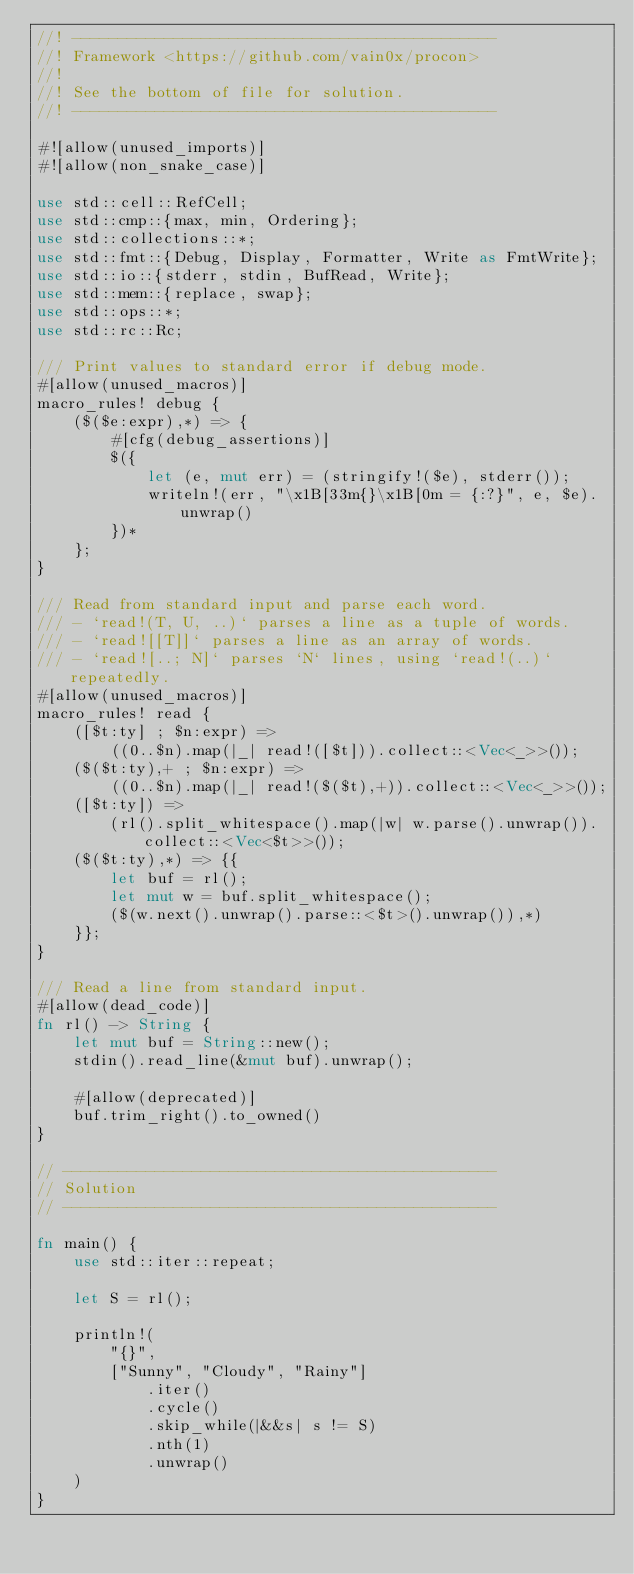Convert code to text. <code><loc_0><loc_0><loc_500><loc_500><_Rust_>//! ----------------------------------------------
//! Framework <https://github.com/vain0x/procon>
//!
//! See the bottom of file for solution.
//! ----------------------------------------------

#![allow(unused_imports)]
#![allow(non_snake_case)]

use std::cell::RefCell;
use std::cmp::{max, min, Ordering};
use std::collections::*;
use std::fmt::{Debug, Display, Formatter, Write as FmtWrite};
use std::io::{stderr, stdin, BufRead, Write};
use std::mem::{replace, swap};
use std::ops::*;
use std::rc::Rc;

/// Print values to standard error if debug mode.
#[allow(unused_macros)]
macro_rules! debug {
    ($($e:expr),*) => {
        #[cfg(debug_assertions)]
        $({
            let (e, mut err) = (stringify!($e), stderr());
            writeln!(err, "\x1B[33m{}\x1B[0m = {:?}", e, $e).unwrap()
        })*
    };
}

/// Read from standard input and parse each word.
/// - `read!(T, U, ..)` parses a line as a tuple of words.
/// - `read![[T]]` parses a line as an array of words.
/// - `read![..; N]` parses `N` lines, using `read!(..)` repeatedly.
#[allow(unused_macros)]
macro_rules! read {
    ([$t:ty] ; $n:expr) =>
        ((0..$n).map(|_| read!([$t])).collect::<Vec<_>>());
    ($($t:ty),+ ; $n:expr) =>
        ((0..$n).map(|_| read!($($t),+)).collect::<Vec<_>>());
    ([$t:ty]) =>
        (rl().split_whitespace().map(|w| w.parse().unwrap()).collect::<Vec<$t>>());
    ($($t:ty),*) => {{
        let buf = rl();
        let mut w = buf.split_whitespace();
        ($(w.next().unwrap().parse::<$t>().unwrap()),*)
    }};
}

/// Read a line from standard input.
#[allow(dead_code)]
fn rl() -> String {
    let mut buf = String::new();
    stdin().read_line(&mut buf).unwrap();

    #[allow(deprecated)]
    buf.trim_right().to_owned()
}

// -----------------------------------------------
// Solution
// -----------------------------------------------

fn main() {
    use std::iter::repeat;

    let S = rl();

    println!(
        "{}",
        ["Sunny", "Cloudy", "Rainy"]
            .iter()
            .cycle()
            .skip_while(|&&s| s != S)
            .nth(1)
            .unwrap()
    )
}
</code> 